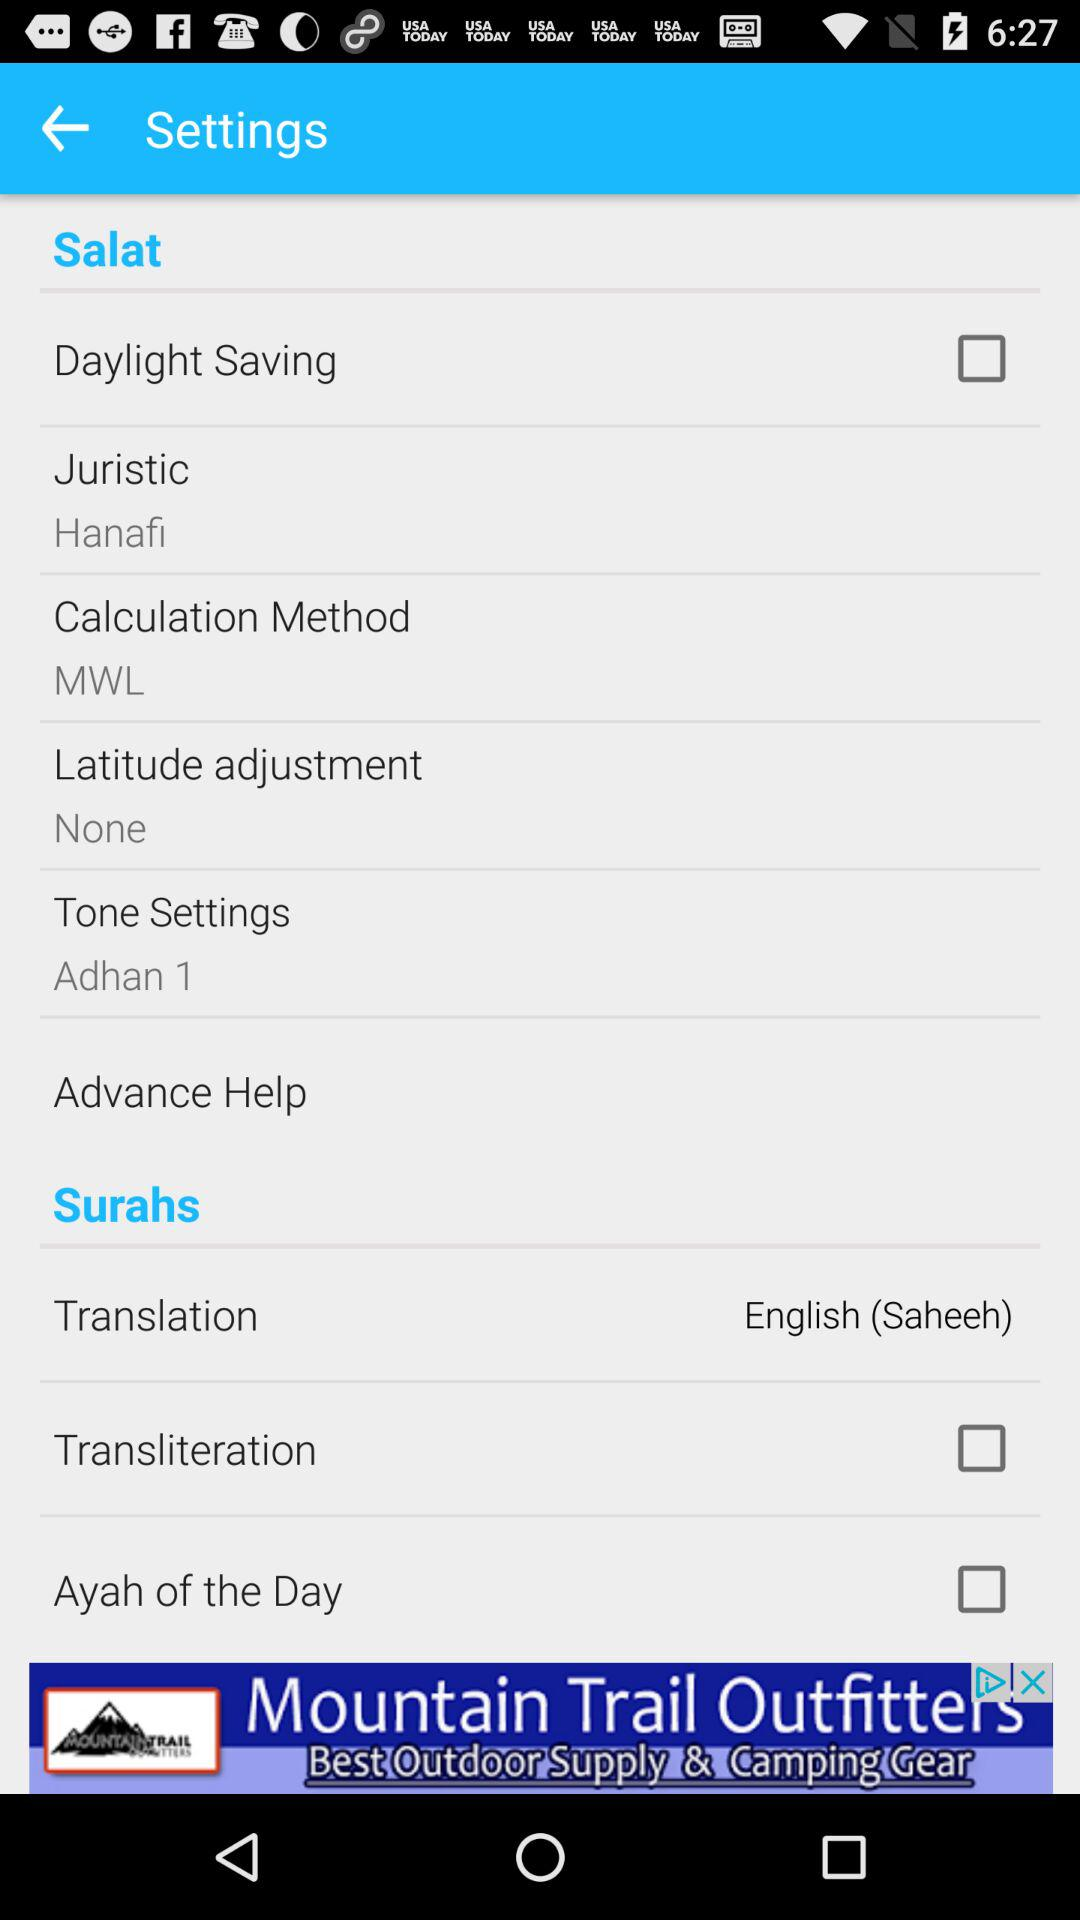What is the selected calculation method? The selected calculation method is MWL. 